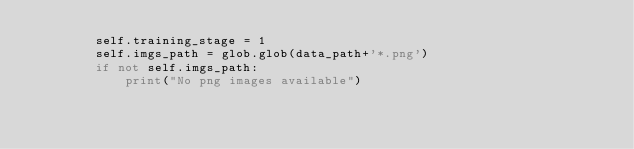Convert code to text. <code><loc_0><loc_0><loc_500><loc_500><_Python_>        self.training_stage = 1
        self.imgs_path = glob.glob(data_path+'*.png')
        if not self.imgs_path:
            print("No png images available")</code> 